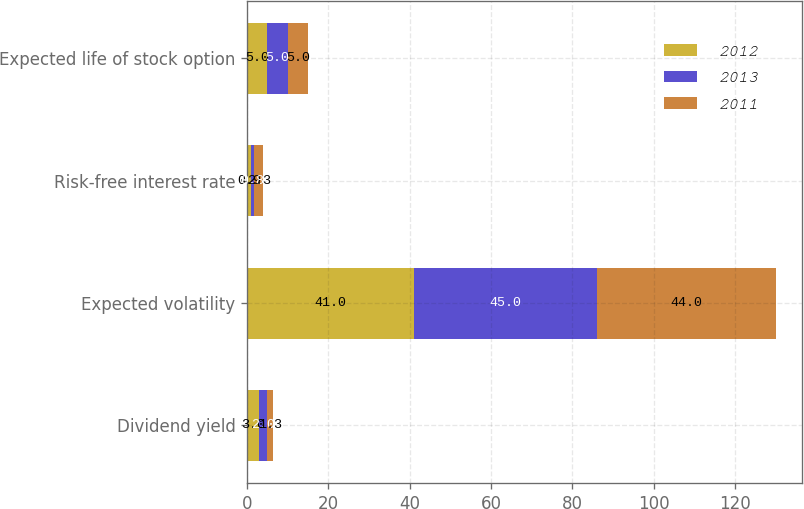<chart> <loc_0><loc_0><loc_500><loc_500><stacked_bar_chart><ecel><fcel>Dividend yield<fcel>Expected volatility<fcel>Risk-free interest rate<fcel>Expected life of stock option<nl><fcel>2012<fcel>3<fcel>41<fcel>0.9<fcel>5<nl><fcel>2013<fcel>2<fcel>45<fcel>0.8<fcel>5<nl><fcel>2011<fcel>1.3<fcel>44<fcel>2.3<fcel>5<nl></chart> 